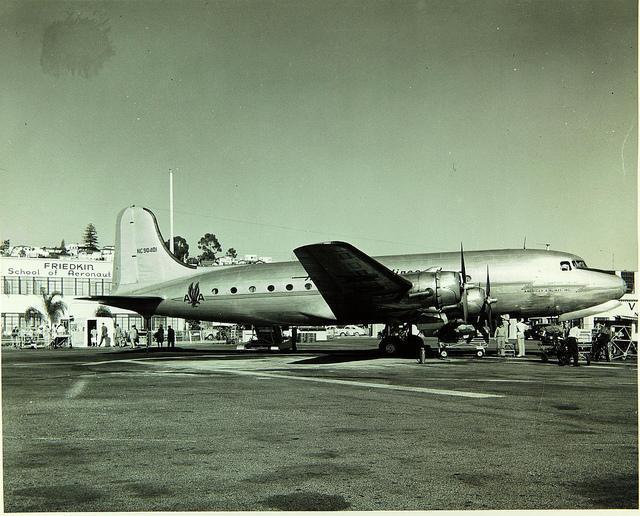How many black dogs are there?
Give a very brief answer. 0. 